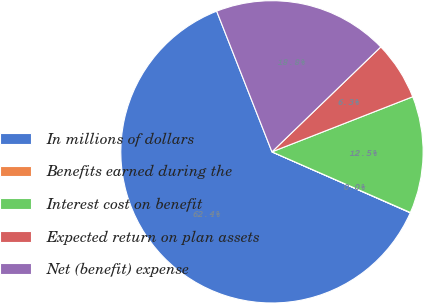Convert chart to OTSL. <chart><loc_0><loc_0><loc_500><loc_500><pie_chart><fcel>In millions of dollars<fcel>Benefits earned during the<fcel>Interest cost on benefit<fcel>Expected return on plan assets<fcel>Net (benefit) expense<nl><fcel>62.43%<fcel>0.03%<fcel>12.51%<fcel>6.27%<fcel>18.75%<nl></chart> 